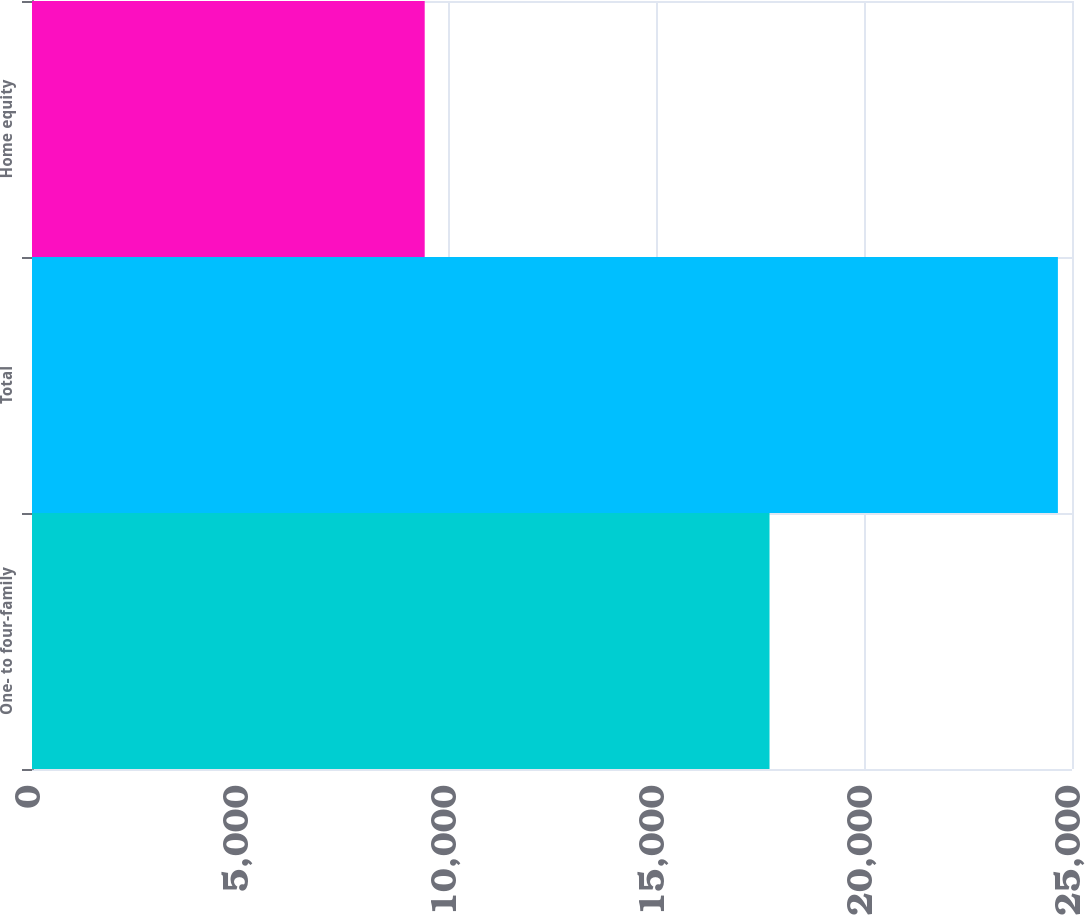Convert chart. <chart><loc_0><loc_0><loc_500><loc_500><bar_chart><fcel>One- to four-family<fcel>Total<fcel>Home equity<nl><fcel>17729<fcel>24661<fcel>9440<nl></chart> 